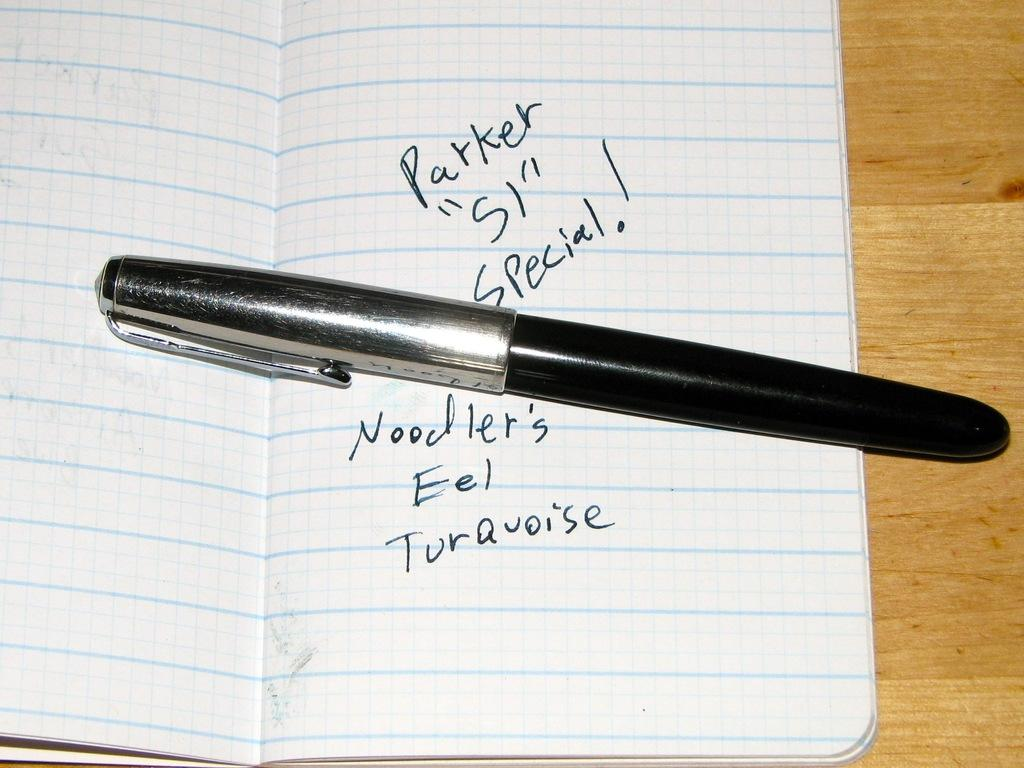What object is present on the book in the image? There is a pen on the book in the image. Where is the book located in the image? The book is on a table in the image. What is the table made of? The table is made of wood. What color is the pen in the image? The pen is black in color. What type of cough can be heard coming from the pen in the image? There is no cough present in the image, as the pen is an inanimate object and cannot produce sounds. 